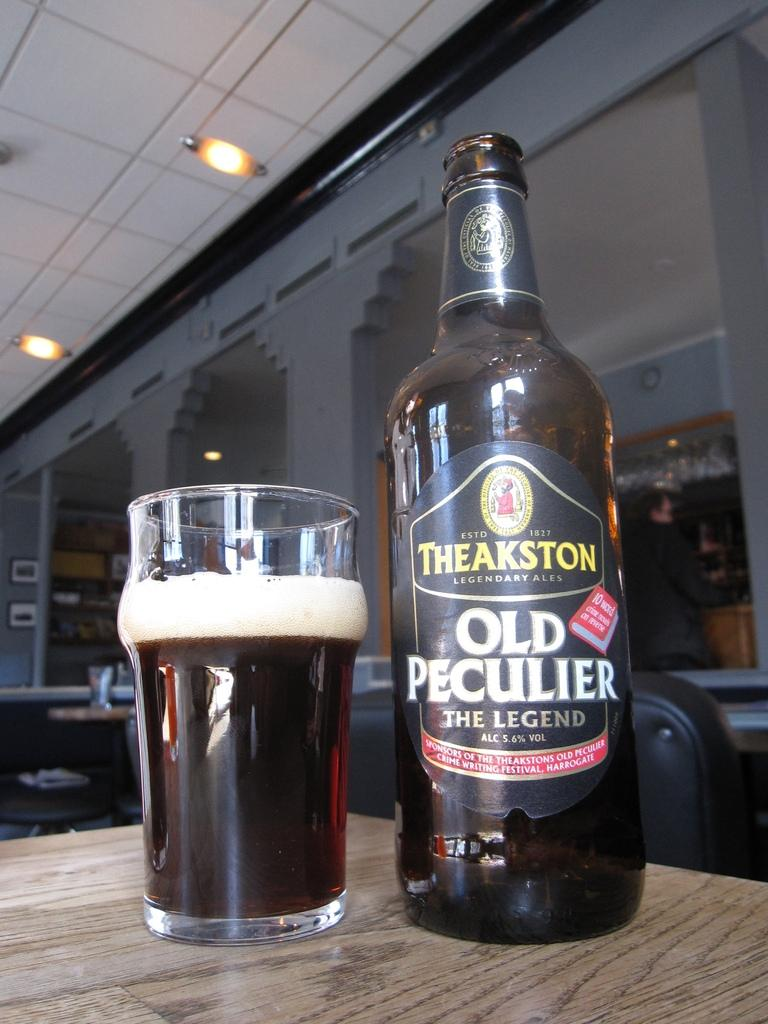<image>
Relay a brief, clear account of the picture shown. A bottle of Theakston Old Peculier is poured into a glass. 